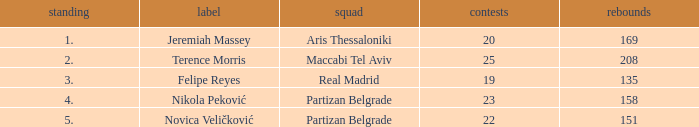How many Games for Terence Morris? 25.0. 